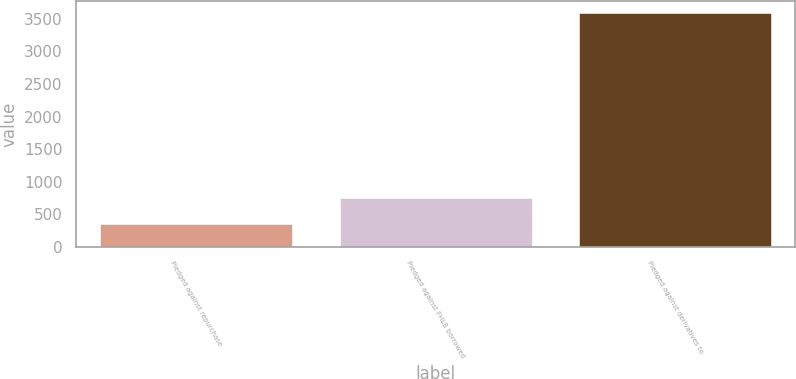Convert chart to OTSL. <chart><loc_0><loc_0><loc_500><loc_500><bar_chart><fcel>Pledged against repurchase<fcel>Pledged against FHLB borrowed<fcel>Pledged against derivatives to<nl><fcel>344<fcel>745<fcel>3592<nl></chart> 